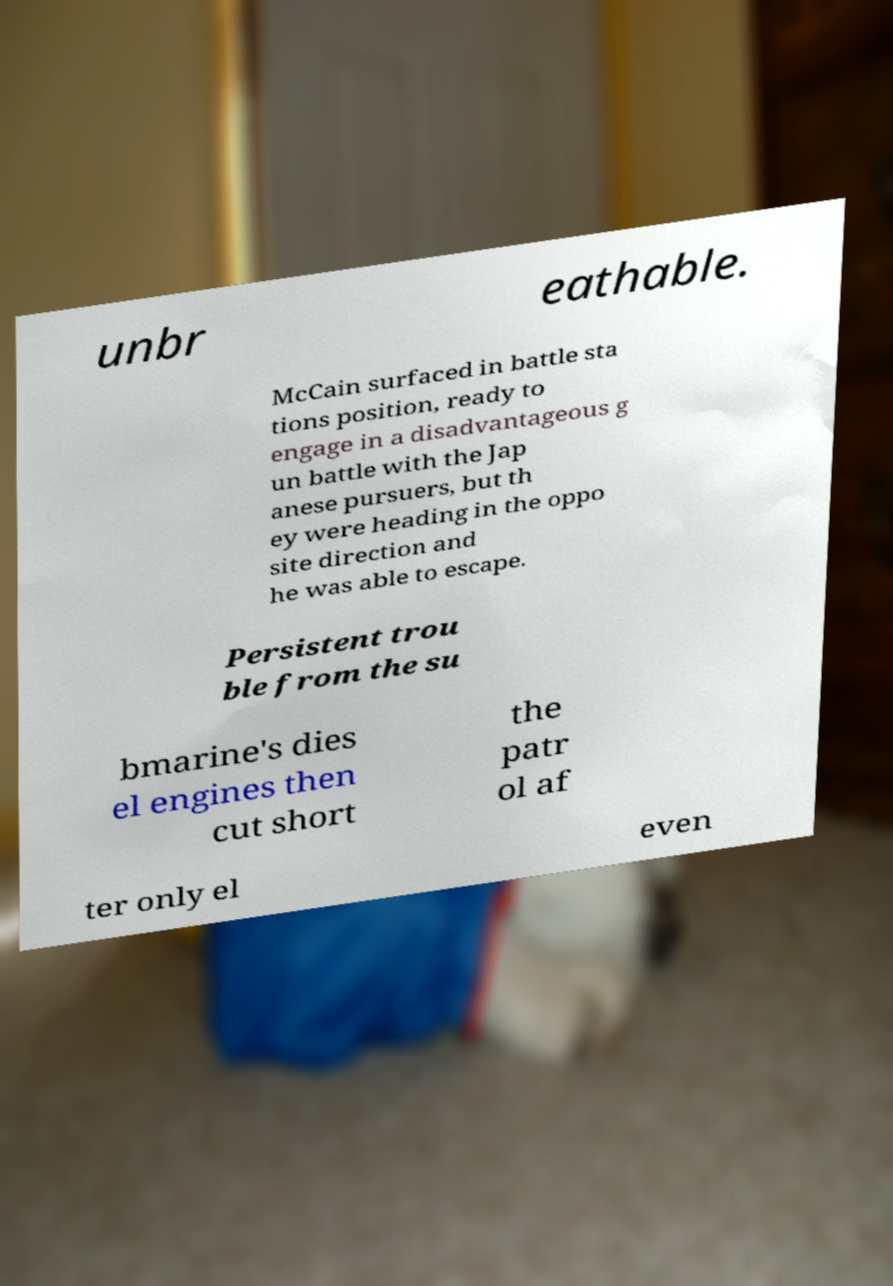There's text embedded in this image that I need extracted. Can you transcribe it verbatim? unbr eathable. McCain surfaced in battle sta tions position, ready to engage in a disadvantageous g un battle with the Jap anese pursuers, but th ey were heading in the oppo site direction and he was able to escape. Persistent trou ble from the su bmarine's dies el engines then cut short the patr ol af ter only el even 